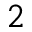<formula> <loc_0><loc_0><loc_500><loc_500>^ { 2 }</formula> 